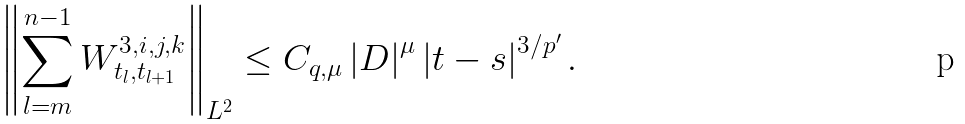<formula> <loc_0><loc_0><loc_500><loc_500>\left \| \sum _ { l = m } ^ { n - 1 } W _ { t _ { l } , t _ { l + 1 } } ^ { 3 , i , j , k } \right \| _ { L ^ { 2 } } \leq C _ { q , \mu } \left | D \right | ^ { \mu } \left | t - s \right | ^ { 3 / p ^ { \prime } } .</formula> 